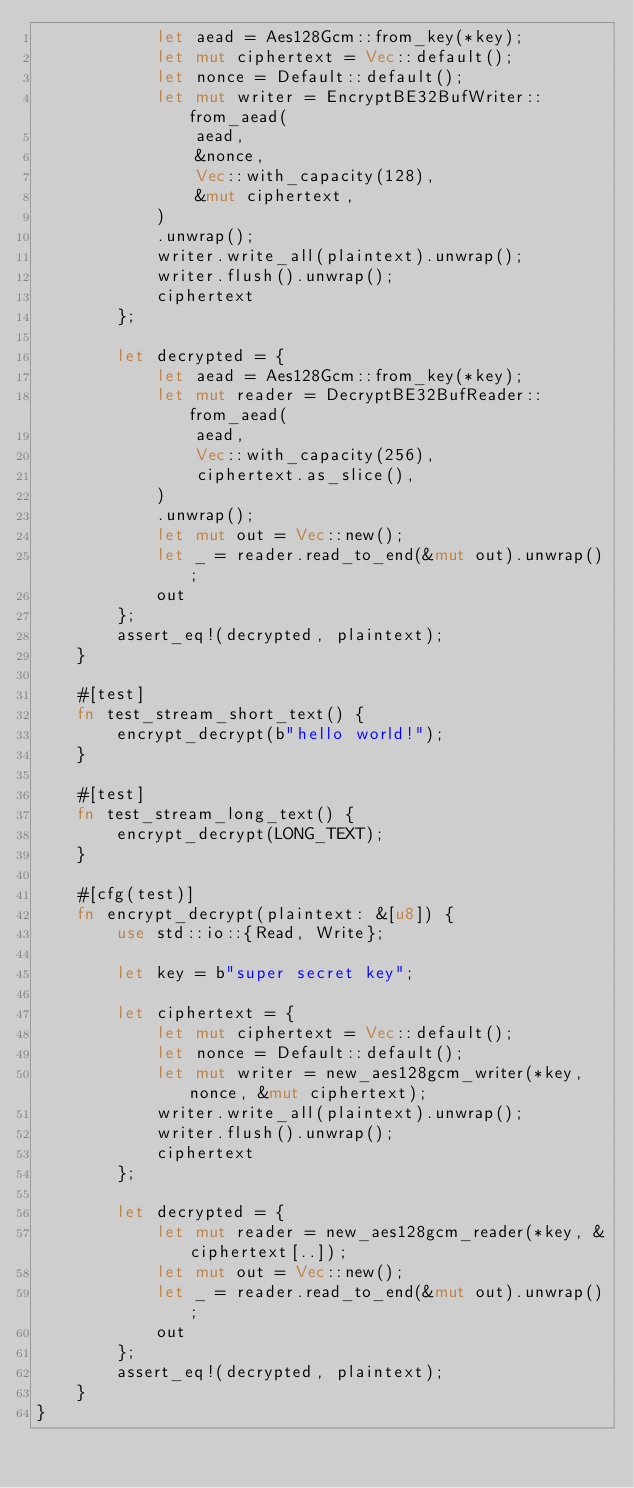Convert code to text. <code><loc_0><loc_0><loc_500><loc_500><_Rust_>            let aead = Aes128Gcm::from_key(*key);
            let mut ciphertext = Vec::default();
            let nonce = Default::default();
            let mut writer = EncryptBE32BufWriter::from_aead(
                aead,
                &nonce,
                Vec::with_capacity(128),
                &mut ciphertext,
            )
            .unwrap();
            writer.write_all(plaintext).unwrap();
            writer.flush().unwrap();
            ciphertext
        };

        let decrypted = {
            let aead = Aes128Gcm::from_key(*key);
            let mut reader = DecryptBE32BufReader::from_aead(
                aead,
                Vec::with_capacity(256),
                ciphertext.as_slice(),
            )
            .unwrap();
            let mut out = Vec::new();
            let _ = reader.read_to_end(&mut out).unwrap();
            out
        };
        assert_eq!(decrypted, plaintext);
    }

    #[test]
    fn test_stream_short_text() {
        encrypt_decrypt(b"hello world!");
    }

    #[test]
    fn test_stream_long_text() {
        encrypt_decrypt(LONG_TEXT);
    }

    #[cfg(test)]
    fn encrypt_decrypt(plaintext: &[u8]) {
        use std::io::{Read, Write};

        let key = b"super secret key";

        let ciphertext = {
            let mut ciphertext = Vec::default();
            let nonce = Default::default();
            let mut writer = new_aes128gcm_writer(*key, nonce, &mut ciphertext);
            writer.write_all(plaintext).unwrap();
            writer.flush().unwrap();
            ciphertext
        };

        let decrypted = {
            let mut reader = new_aes128gcm_reader(*key, &ciphertext[..]);
            let mut out = Vec::new();
            let _ = reader.read_to_end(&mut out).unwrap();
            out
        };
        assert_eq!(decrypted, plaintext);
    }
}
</code> 